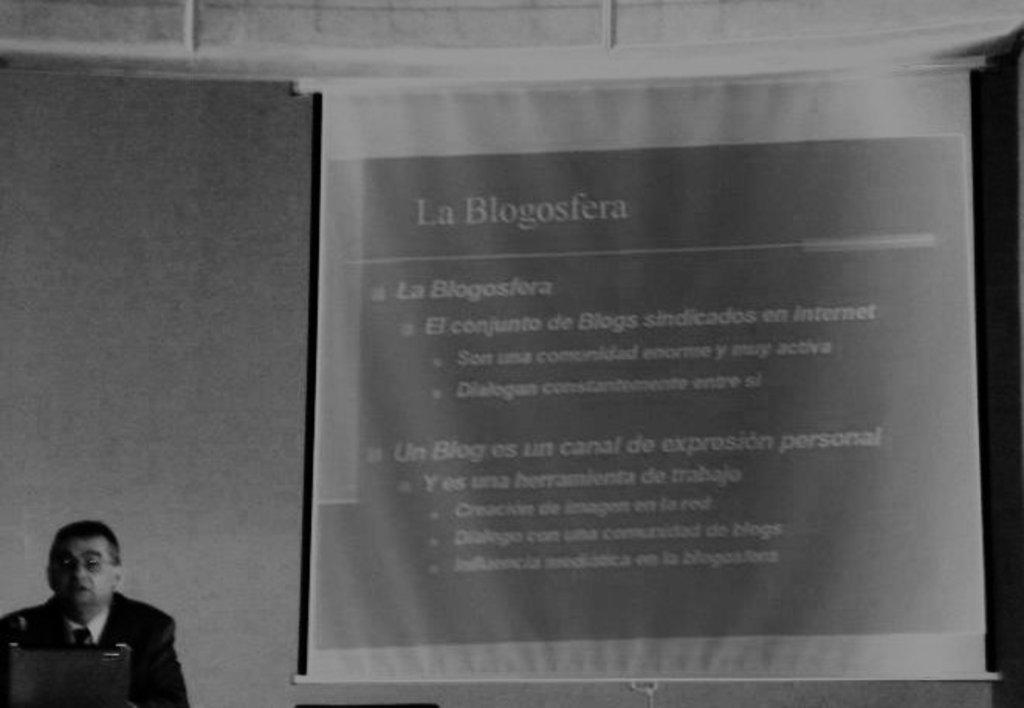What is the main focus of the image? The main focus of the image is a screen with text in the center. Who or what is on the left side of the image? There is a person and a laptop on the left side of the image. What level of difficulty is the person facing on the screen? The facts provided do not give any information about the difficulty level of the text on the screen. --- Facts: 1. There is a person in the image. 2. The person is wearing a hat. 3. The person is holding a book. Absurd Topics: pet, ocean Conversation: Who or what is the main subject in the image? The main subject in the image is a person. What is the person wearing in the image? The person is wearing a hat in the image. What is the person holding in the image? The person is holding a book in the image. Reasoning: Let's think step by step in order to produce the conversation. We start by identifying the main subject of the image, which is a person. Then, we describe specific features of the person, such as the hat. Finally, we observe the actions of the person, noting that they are holding a book. Absurd Question/Answer: Can you see the person's pet in the image? There is no mention of a pet in the image. --- Facts: 1. There is a car in the image. 2. The car is red. 3. The car has four wheels. Absurd Topics: dance, music Conversation: What is the main subject in the image? The main subject in the image is a car. What color is the car in the image? The car is red in the image. How many wheels does the car have in the image? The car has four wheels in the image. Reasoning: Let's think step by step in order to produce the conversation. We start by identifying the main subject of the image, which is a car. Then, we describe specific features of the car, such as the color and the number of wheels. Each question is designed to elicit a specific detail about the image that is known from the provided facts. Absurd Question/Answer: What type of music can be heard coming from the car in the image? There is no mention of music in the image. --- Facts: 1. There is a person sitting on a chair in the image. 2. The person is holding a cup of coffee. 3. There is a table next to the chair. Absurd Topics: elephant, circus Conversation: Who or what is the main subject in the image? The main subject in the image is a person sitting on a chair. What is the person holding in the image? The person is holding a cup of coffee in the image. 